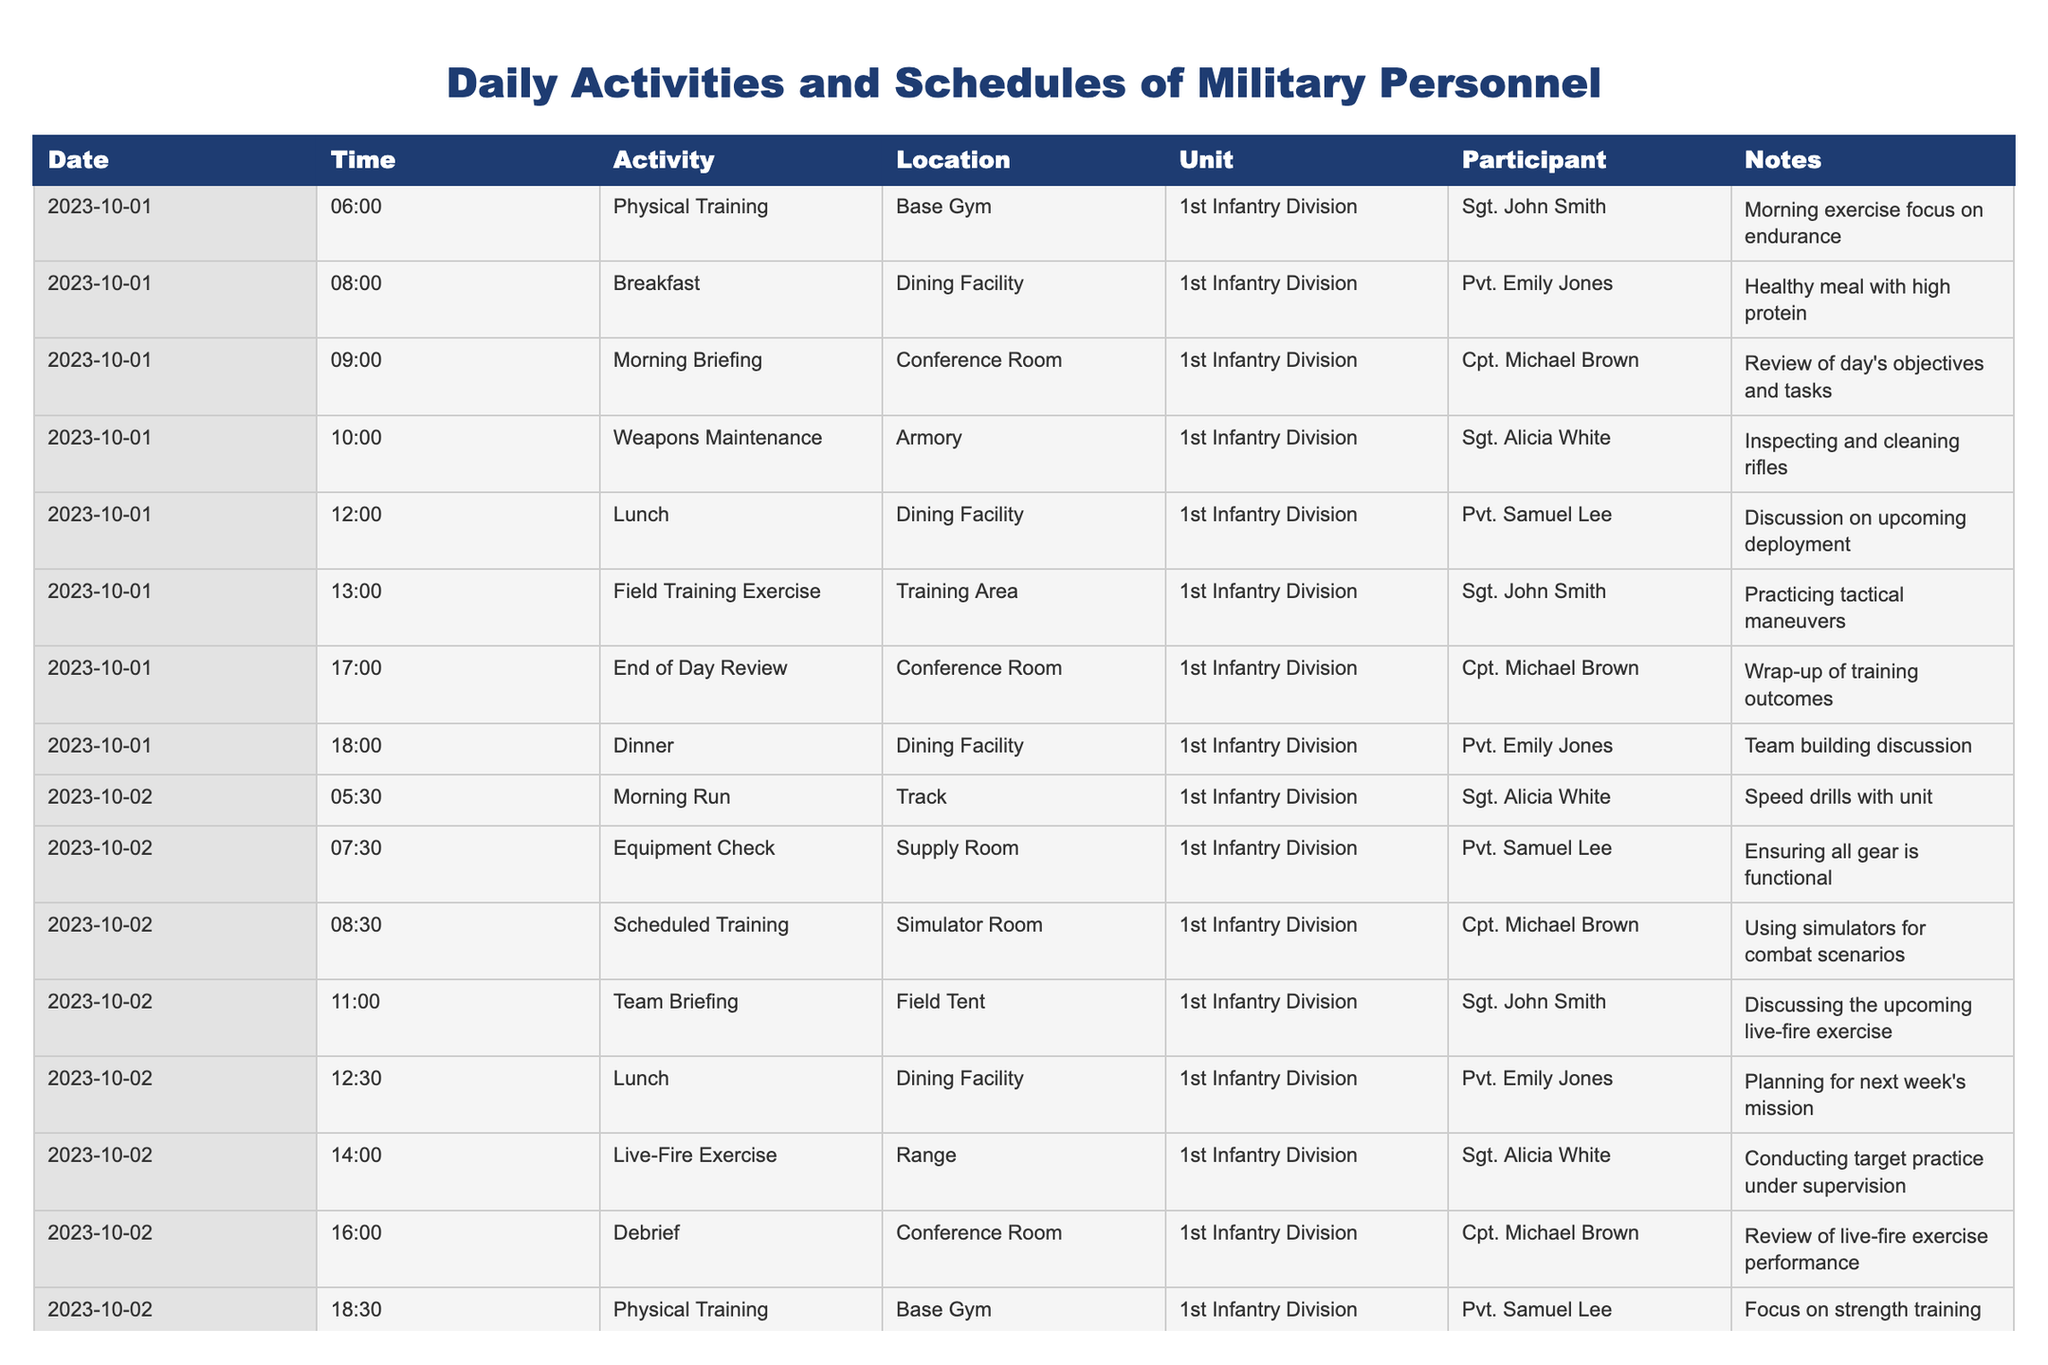What activity is scheduled at 08:00 on 2023-10-01? Referring to the table, at 08:00 on 2023-10-01, the activity listed is "Breakfast."
Answer: Breakfast How many activities are scheduled for 2023-10-02? There are 8 entries for 2023-10-02 in the table, indicating 8 activities.
Answer: 8 Which participant is involved in the "Live-Fire Exercise"? Looking at the table for the activity "Live-Fire Exercise," it shows that "Sgt. Alicia White" is the participant for this event.
Answer: Sgt. Alicia White What is the last activity listed for 2023-10-03? The last activity for 2023-10-03 is found by checking the last entry of the day, which shows "Team Huddle" at 17:00.
Answer: Team Huddle Did Cpt. Michael Brown participate in any activities on 2023-10-03? A review of the table indicates that Cpt. Michael Brown has two entries on 2023-10-03: "Medical Check-Up" and "End of Day Review."
Answer: Yes On which day is the "Field Training Exercise" planned? By scanning through the table, the "Field Training Exercise" is scheduled for 2023-10-01 at 13:00.
Answer: 2023-10-01 What is the focus of the Physical Training on 2023-10-02? Checking the details, the Physical Training at 18:30 on 2023-10-02 had a focus on strength training.
Answer: Strength training How many meals are served each day based on the schedule? Analyzing the table shows that there are three meals listed: Breakfast, Lunch, and Dinner on each day, confirming three meals.
Answer: 3 Which unit has all these scheduled activities? The entries in the table indicate that all activities are under the "1st Infantry Division."
Answer: 1st Infantry Division How many unique participants are involved across the recorded dates? By reviewing the participant names in each entry across the dates, the unique names are: Sgt. John Smith, Pvt. Emily Jones, Cpt. Michael Brown, Sgt. Alicia White, and Pvt. Samuel Lee, totaling five unique participants.
Answer: 5 